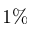<formula> <loc_0><loc_0><loc_500><loc_500>1 \%</formula> 